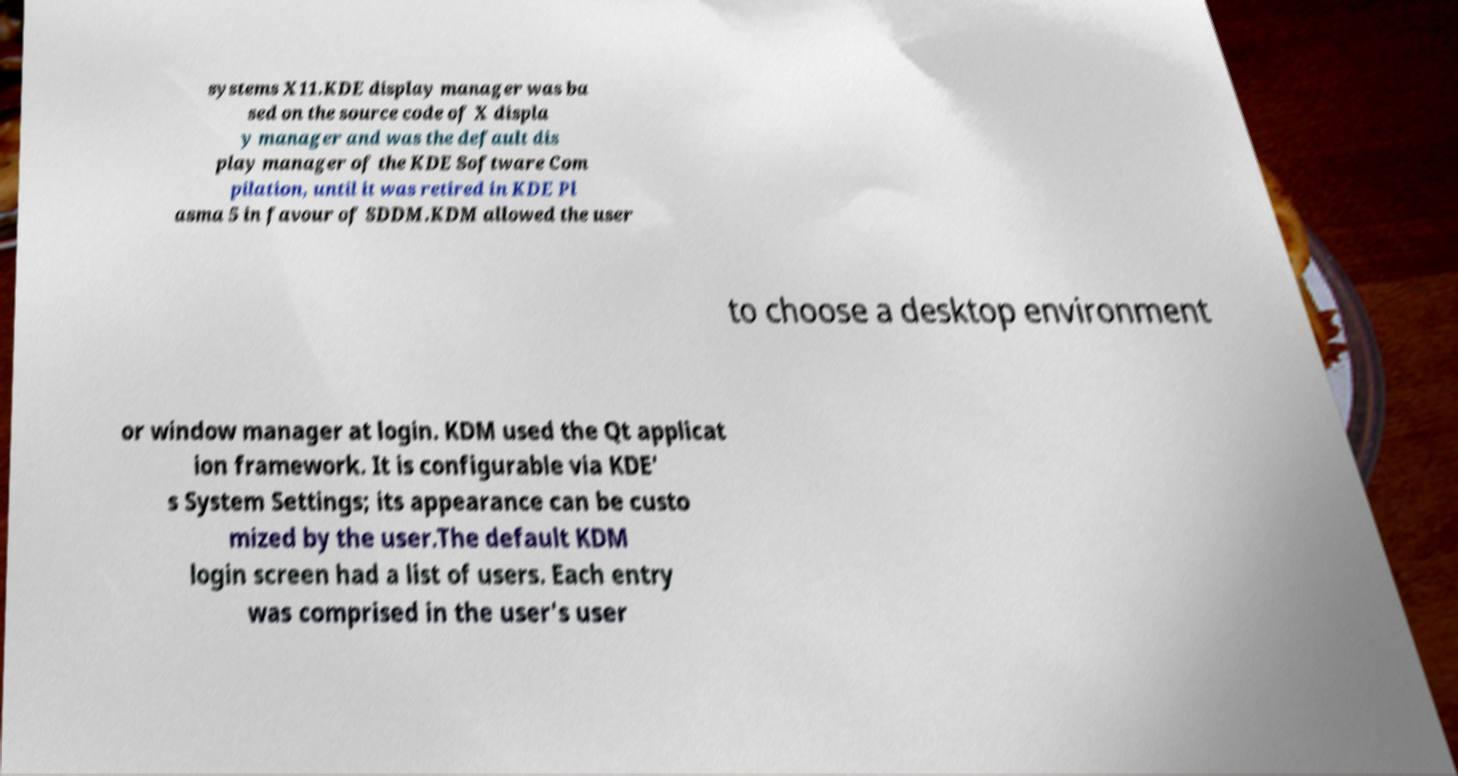Can you read and provide the text displayed in the image?This photo seems to have some interesting text. Can you extract and type it out for me? systems X11.KDE display manager was ba sed on the source code of X displa y manager and was the default dis play manager of the KDE Software Com pilation, until it was retired in KDE Pl asma 5 in favour of SDDM.KDM allowed the user to choose a desktop environment or window manager at login. KDM used the Qt applicat ion framework. It is configurable via KDE' s System Settings; its appearance can be custo mized by the user.The default KDM login screen had a list of users. Each entry was comprised in the user's user 